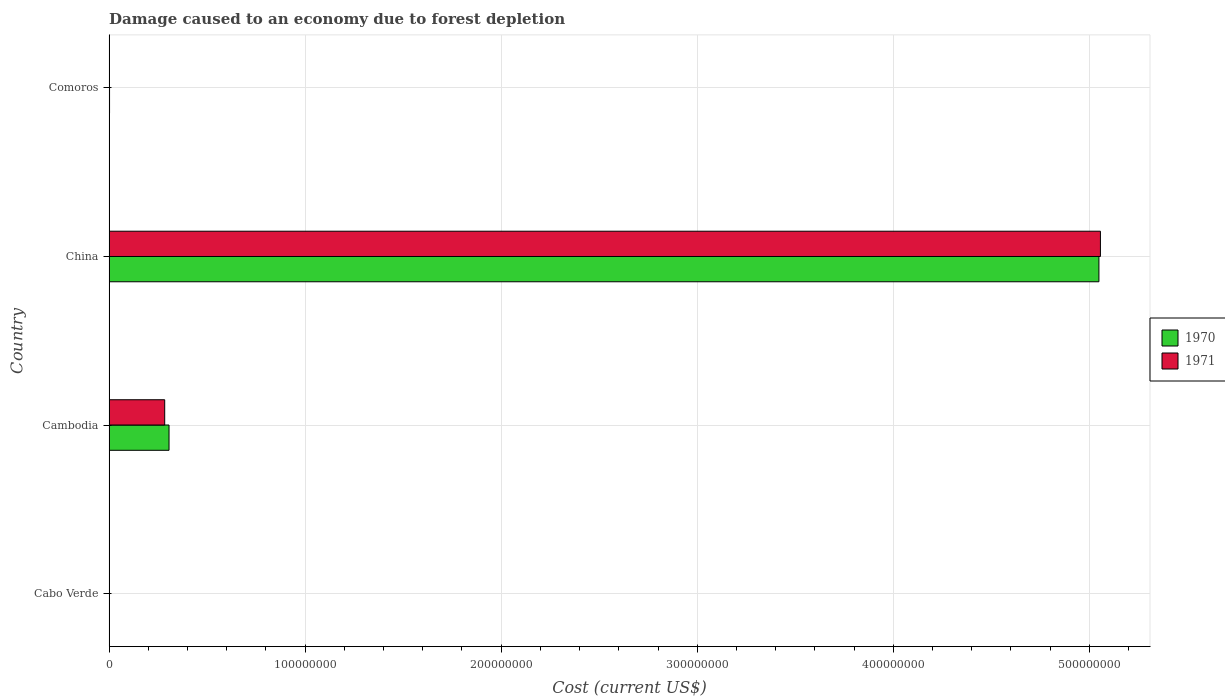How many groups of bars are there?
Make the answer very short. 4. Are the number of bars per tick equal to the number of legend labels?
Give a very brief answer. Yes. How many bars are there on the 4th tick from the bottom?
Provide a short and direct response. 2. What is the label of the 1st group of bars from the top?
Offer a very short reply. Comoros. In how many cases, is the number of bars for a given country not equal to the number of legend labels?
Your answer should be very brief. 0. What is the cost of damage caused due to forest depletion in 1970 in Cambodia?
Ensure brevity in your answer.  3.06e+07. Across all countries, what is the maximum cost of damage caused due to forest depletion in 1971?
Keep it short and to the point. 5.06e+08. Across all countries, what is the minimum cost of damage caused due to forest depletion in 1970?
Offer a very short reply. 2.02e+05. In which country was the cost of damage caused due to forest depletion in 1971 minimum?
Provide a short and direct response. Cabo Verde. What is the total cost of damage caused due to forest depletion in 1970 in the graph?
Make the answer very short. 5.36e+08. What is the difference between the cost of damage caused due to forest depletion in 1971 in Cabo Verde and that in Comoros?
Keep it short and to the point. -3.18e+04. What is the difference between the cost of damage caused due to forest depletion in 1971 in Cambodia and the cost of damage caused due to forest depletion in 1970 in Cabo Verde?
Your answer should be very brief. 2.82e+07. What is the average cost of damage caused due to forest depletion in 1970 per country?
Offer a terse response. 1.34e+08. What is the difference between the cost of damage caused due to forest depletion in 1970 and cost of damage caused due to forest depletion in 1971 in China?
Provide a short and direct response. -7.69e+05. In how many countries, is the cost of damage caused due to forest depletion in 1970 greater than 420000000 US$?
Provide a short and direct response. 1. What is the ratio of the cost of damage caused due to forest depletion in 1970 in Cabo Verde to that in Cambodia?
Provide a short and direct response. 0.01. Is the cost of damage caused due to forest depletion in 1970 in Cabo Verde less than that in China?
Provide a short and direct response. Yes. Is the difference between the cost of damage caused due to forest depletion in 1970 in Cabo Verde and Cambodia greater than the difference between the cost of damage caused due to forest depletion in 1971 in Cabo Verde and Cambodia?
Your answer should be very brief. No. What is the difference between the highest and the second highest cost of damage caused due to forest depletion in 1970?
Your answer should be very brief. 4.74e+08. What is the difference between the highest and the lowest cost of damage caused due to forest depletion in 1970?
Ensure brevity in your answer.  5.05e+08. In how many countries, is the cost of damage caused due to forest depletion in 1971 greater than the average cost of damage caused due to forest depletion in 1971 taken over all countries?
Offer a very short reply. 1. Is the sum of the cost of damage caused due to forest depletion in 1970 in Cambodia and China greater than the maximum cost of damage caused due to forest depletion in 1971 across all countries?
Provide a short and direct response. Yes. What does the 2nd bar from the top in China represents?
Offer a very short reply. 1970. Are all the bars in the graph horizontal?
Your answer should be very brief. Yes. How many countries are there in the graph?
Offer a very short reply. 4. Where does the legend appear in the graph?
Provide a short and direct response. Center right. How are the legend labels stacked?
Your answer should be compact. Vertical. What is the title of the graph?
Give a very brief answer. Damage caused to an economy due to forest depletion. Does "1989" appear as one of the legend labels in the graph?
Your response must be concise. No. What is the label or title of the X-axis?
Ensure brevity in your answer.  Cost (current US$). What is the Cost (current US$) in 1970 in Cabo Verde?
Give a very brief answer. 2.02e+05. What is the Cost (current US$) of 1971 in Cabo Verde?
Provide a short and direct response. 1.81e+05. What is the Cost (current US$) of 1970 in Cambodia?
Make the answer very short. 3.06e+07. What is the Cost (current US$) in 1971 in Cambodia?
Give a very brief answer. 2.84e+07. What is the Cost (current US$) of 1970 in China?
Offer a very short reply. 5.05e+08. What is the Cost (current US$) of 1971 in China?
Your answer should be very brief. 5.06e+08. What is the Cost (current US$) of 1970 in Comoros?
Provide a short and direct response. 2.49e+05. What is the Cost (current US$) of 1971 in Comoros?
Your answer should be very brief. 2.13e+05. Across all countries, what is the maximum Cost (current US$) in 1970?
Offer a terse response. 5.05e+08. Across all countries, what is the maximum Cost (current US$) of 1971?
Provide a succinct answer. 5.06e+08. Across all countries, what is the minimum Cost (current US$) of 1970?
Keep it short and to the point. 2.02e+05. Across all countries, what is the minimum Cost (current US$) of 1971?
Provide a succinct answer. 1.81e+05. What is the total Cost (current US$) of 1970 in the graph?
Your answer should be compact. 5.36e+08. What is the total Cost (current US$) of 1971 in the graph?
Your answer should be compact. 5.34e+08. What is the difference between the Cost (current US$) in 1970 in Cabo Verde and that in Cambodia?
Ensure brevity in your answer.  -3.04e+07. What is the difference between the Cost (current US$) in 1971 in Cabo Verde and that in Cambodia?
Offer a terse response. -2.82e+07. What is the difference between the Cost (current US$) of 1970 in Cabo Verde and that in China?
Give a very brief answer. -5.05e+08. What is the difference between the Cost (current US$) in 1971 in Cabo Verde and that in China?
Offer a terse response. -5.05e+08. What is the difference between the Cost (current US$) in 1970 in Cabo Verde and that in Comoros?
Offer a terse response. -4.65e+04. What is the difference between the Cost (current US$) in 1971 in Cabo Verde and that in Comoros?
Provide a succinct answer. -3.18e+04. What is the difference between the Cost (current US$) of 1970 in Cambodia and that in China?
Your answer should be very brief. -4.74e+08. What is the difference between the Cost (current US$) of 1971 in Cambodia and that in China?
Your answer should be compact. -4.77e+08. What is the difference between the Cost (current US$) in 1970 in Cambodia and that in Comoros?
Provide a succinct answer. 3.03e+07. What is the difference between the Cost (current US$) of 1971 in Cambodia and that in Comoros?
Your answer should be compact. 2.82e+07. What is the difference between the Cost (current US$) of 1970 in China and that in Comoros?
Make the answer very short. 5.05e+08. What is the difference between the Cost (current US$) of 1971 in China and that in Comoros?
Ensure brevity in your answer.  5.05e+08. What is the difference between the Cost (current US$) of 1970 in Cabo Verde and the Cost (current US$) of 1971 in Cambodia?
Your answer should be very brief. -2.82e+07. What is the difference between the Cost (current US$) in 1970 in Cabo Verde and the Cost (current US$) in 1971 in China?
Provide a short and direct response. -5.05e+08. What is the difference between the Cost (current US$) in 1970 in Cabo Verde and the Cost (current US$) in 1971 in Comoros?
Provide a succinct answer. -1.02e+04. What is the difference between the Cost (current US$) of 1970 in Cambodia and the Cost (current US$) of 1971 in China?
Offer a terse response. -4.75e+08. What is the difference between the Cost (current US$) in 1970 in Cambodia and the Cost (current US$) in 1971 in Comoros?
Your response must be concise. 3.04e+07. What is the difference between the Cost (current US$) of 1970 in China and the Cost (current US$) of 1971 in Comoros?
Provide a succinct answer. 5.05e+08. What is the average Cost (current US$) of 1970 per country?
Offer a very short reply. 1.34e+08. What is the average Cost (current US$) in 1971 per country?
Ensure brevity in your answer.  1.34e+08. What is the difference between the Cost (current US$) in 1970 and Cost (current US$) in 1971 in Cabo Verde?
Offer a terse response. 2.17e+04. What is the difference between the Cost (current US$) of 1970 and Cost (current US$) of 1971 in Cambodia?
Your response must be concise. 2.21e+06. What is the difference between the Cost (current US$) of 1970 and Cost (current US$) of 1971 in China?
Provide a short and direct response. -7.69e+05. What is the difference between the Cost (current US$) of 1970 and Cost (current US$) of 1971 in Comoros?
Ensure brevity in your answer.  3.63e+04. What is the ratio of the Cost (current US$) in 1970 in Cabo Verde to that in Cambodia?
Ensure brevity in your answer.  0.01. What is the ratio of the Cost (current US$) in 1971 in Cabo Verde to that in Cambodia?
Your answer should be compact. 0.01. What is the ratio of the Cost (current US$) of 1970 in Cabo Verde to that in Comoros?
Give a very brief answer. 0.81. What is the ratio of the Cost (current US$) of 1971 in Cabo Verde to that in Comoros?
Give a very brief answer. 0.85. What is the ratio of the Cost (current US$) of 1970 in Cambodia to that in China?
Your answer should be compact. 0.06. What is the ratio of the Cost (current US$) in 1971 in Cambodia to that in China?
Provide a succinct answer. 0.06. What is the ratio of the Cost (current US$) of 1970 in Cambodia to that in Comoros?
Your response must be concise. 122.87. What is the ratio of the Cost (current US$) in 1971 in Cambodia to that in Comoros?
Offer a very short reply. 133.44. What is the ratio of the Cost (current US$) in 1970 in China to that in Comoros?
Your answer should be compact. 2028.18. What is the ratio of the Cost (current US$) of 1971 in China to that in Comoros?
Provide a short and direct response. 2377.93. What is the difference between the highest and the second highest Cost (current US$) of 1970?
Your answer should be very brief. 4.74e+08. What is the difference between the highest and the second highest Cost (current US$) of 1971?
Make the answer very short. 4.77e+08. What is the difference between the highest and the lowest Cost (current US$) in 1970?
Make the answer very short. 5.05e+08. What is the difference between the highest and the lowest Cost (current US$) in 1971?
Give a very brief answer. 5.05e+08. 